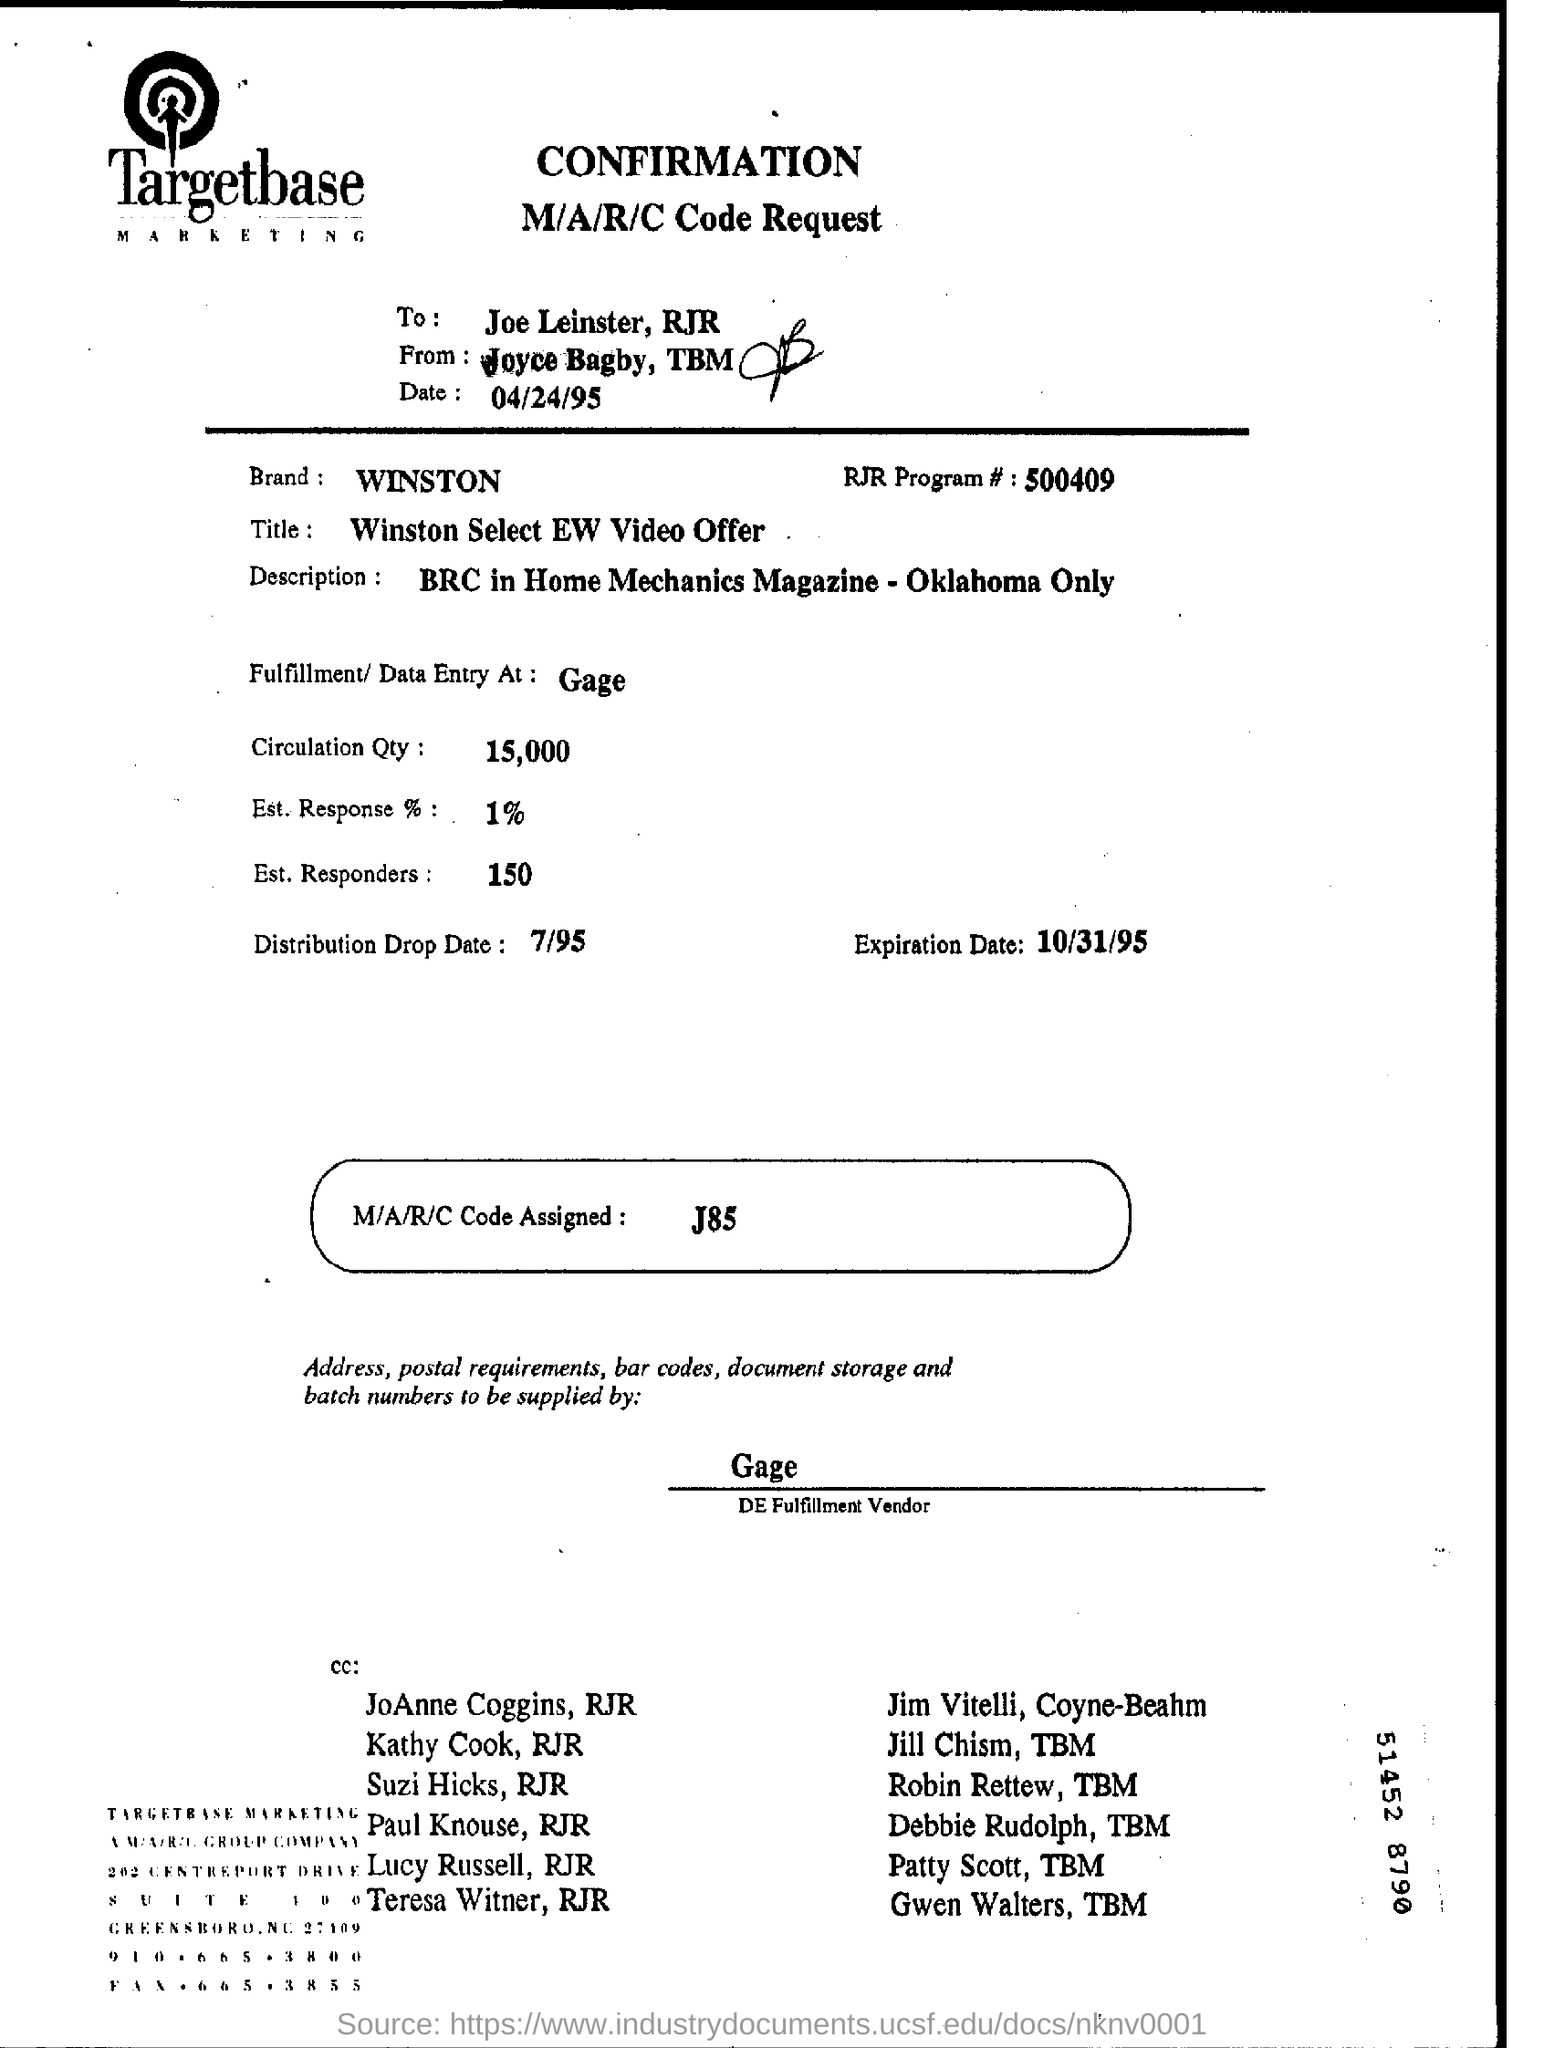To whom is the code request addressed to?
Ensure brevity in your answer.  Joe Leinster. What is the Brand mentioned?
Your answer should be very brief. Winston. What is the expiration date?
Your answer should be compact. 10/31/95. What is the circulation quantity?
Your answer should be very brief. 15,000. What is the name of DE fulfilment Vendor?
Ensure brevity in your answer.  Gage. What is the assigned M/A/R/C code?
Make the answer very short. J85. 